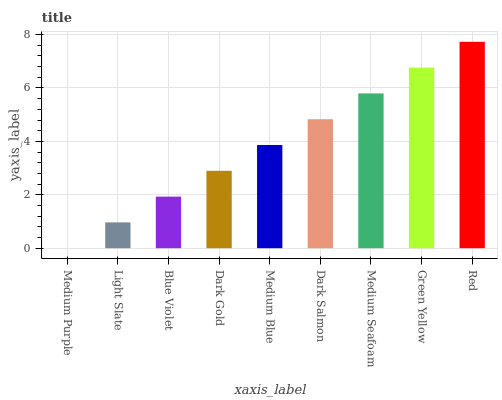Is Medium Purple the minimum?
Answer yes or no. Yes. Is Red the maximum?
Answer yes or no. Yes. Is Light Slate the minimum?
Answer yes or no. No. Is Light Slate the maximum?
Answer yes or no. No. Is Light Slate greater than Medium Purple?
Answer yes or no. Yes. Is Medium Purple less than Light Slate?
Answer yes or no. Yes. Is Medium Purple greater than Light Slate?
Answer yes or no. No. Is Light Slate less than Medium Purple?
Answer yes or no. No. Is Medium Blue the high median?
Answer yes or no. Yes. Is Medium Blue the low median?
Answer yes or no. Yes. Is Medium Purple the high median?
Answer yes or no. No. Is Light Slate the low median?
Answer yes or no. No. 